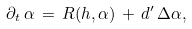<formula> <loc_0><loc_0><loc_500><loc_500>\partial _ { t } \, \alpha \, = \, R ( h , \alpha ) \, + \, d ^ { \prime } \, \Delta \alpha ,</formula> 